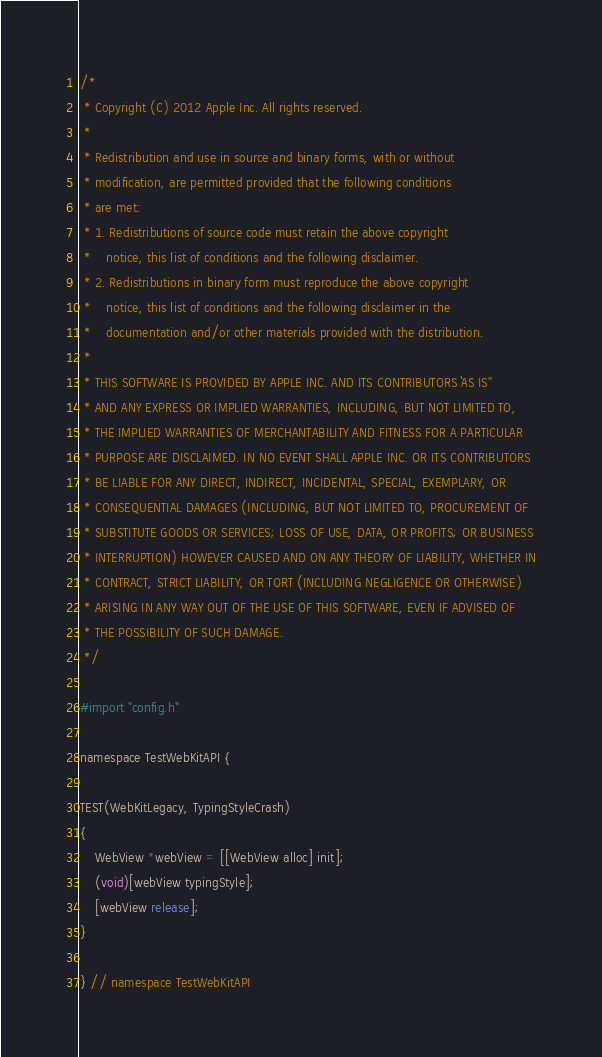Convert code to text. <code><loc_0><loc_0><loc_500><loc_500><_ObjectiveC_>/*
 * Copyright (C) 2012 Apple Inc. All rights reserved.
 *
 * Redistribution and use in source and binary forms, with or without
 * modification, are permitted provided that the following conditions
 * are met:
 * 1. Redistributions of source code must retain the above copyright
 *    notice, this list of conditions and the following disclaimer.
 * 2. Redistributions in binary form must reproduce the above copyright
 *    notice, this list of conditions and the following disclaimer in the
 *    documentation and/or other materials provided with the distribution.
 *
 * THIS SOFTWARE IS PROVIDED BY APPLE INC. AND ITS CONTRIBUTORS ``AS IS''
 * AND ANY EXPRESS OR IMPLIED WARRANTIES, INCLUDING, BUT NOT LIMITED TO,
 * THE IMPLIED WARRANTIES OF MERCHANTABILITY AND FITNESS FOR A PARTICULAR
 * PURPOSE ARE DISCLAIMED. IN NO EVENT SHALL APPLE INC. OR ITS CONTRIBUTORS
 * BE LIABLE FOR ANY DIRECT, INDIRECT, INCIDENTAL, SPECIAL, EXEMPLARY, OR
 * CONSEQUENTIAL DAMAGES (INCLUDING, BUT NOT LIMITED TO, PROCUREMENT OF
 * SUBSTITUTE GOODS OR SERVICES; LOSS OF USE, DATA, OR PROFITS; OR BUSINESS
 * INTERRUPTION) HOWEVER CAUSED AND ON ANY THEORY OF LIABILITY, WHETHER IN
 * CONTRACT, STRICT LIABILITY, OR TORT (INCLUDING NEGLIGENCE OR OTHERWISE)
 * ARISING IN ANY WAY OUT OF THE USE OF THIS SOFTWARE, EVEN IF ADVISED OF
 * THE POSSIBILITY OF SUCH DAMAGE.
 */

#import "config.h"

namespace TestWebKitAPI {

TEST(WebKitLegacy, TypingStyleCrash)
{
    WebView *webView = [[WebView alloc] init];
    (void)[webView typingStyle];
    [webView release];
}

} // namespace TestWebKitAPI
</code> 